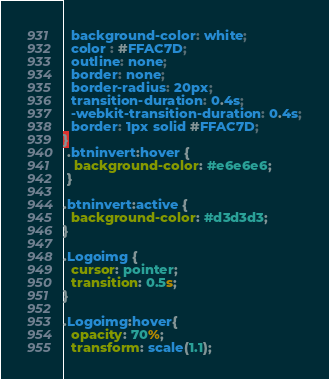<code> <loc_0><loc_0><loc_500><loc_500><_CSS_>  background-color: white;
  color : #FFAC7D;
  outline: none;
  border: none;
  border-radius: 20px;
  transition-duration: 0.4s;
  -webkit-transition-duration: 0.4s;
  border: 1px solid #FFAC7D;
}
 .btninvert:hover { 
   background-color: #e6e6e6;
 }

.btninvert:active {
  background-color: #d3d3d3;
}

.Logoimg { 
  cursor: pointer;
  transition: 0.5s;
}

.Logoimg:hover{
  opacity: 70%;
  transform: scale(1.1);</code> 